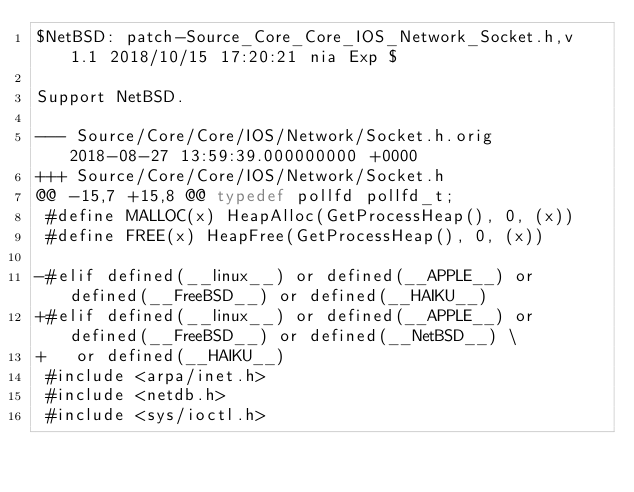<code> <loc_0><loc_0><loc_500><loc_500><_C_>$NetBSD: patch-Source_Core_Core_IOS_Network_Socket.h,v 1.1 2018/10/15 17:20:21 nia Exp $

Support NetBSD.

--- Source/Core/Core/IOS/Network/Socket.h.orig	2018-08-27 13:59:39.000000000 +0000
+++ Source/Core/Core/IOS/Network/Socket.h
@@ -15,7 +15,8 @@ typedef pollfd pollfd_t;
 #define MALLOC(x) HeapAlloc(GetProcessHeap(), 0, (x))
 #define FREE(x) HeapFree(GetProcessHeap(), 0, (x))
 
-#elif defined(__linux__) or defined(__APPLE__) or defined(__FreeBSD__) or defined(__HAIKU__)
+#elif defined(__linux__) or defined(__APPLE__) or defined(__FreeBSD__) or defined(__NetBSD__) \
+   or defined(__HAIKU__)
 #include <arpa/inet.h>
 #include <netdb.h>
 #include <sys/ioctl.h>
</code> 